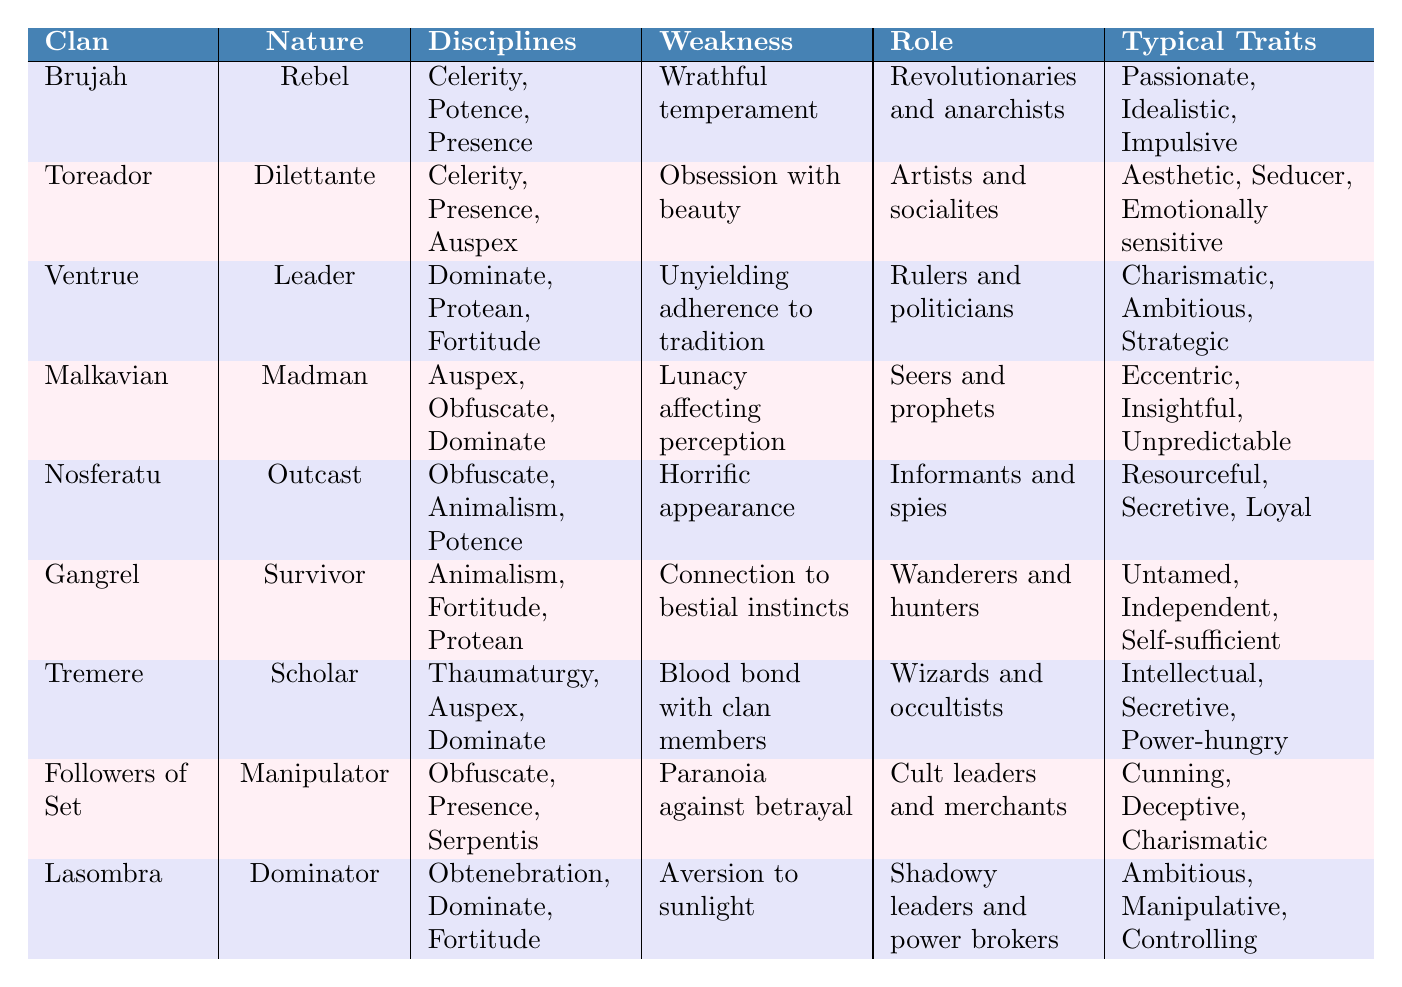What is the typical trait of the Ventrue clan? The table lists the typical traits of the Ventrue clan, which are Charismatic, Ambitious, and Strategic.
Answer: Charismatic, Ambitious, Strategic Which clan has the weakness of “Horrific appearance”? The table indicates that the Nosferatu clan has the weakness of “Horrific appearance.”
Answer: Nosferatu What are the disciplines practiced by the Toreador clan? According to the table, the Toreador clan practices Celerity, Presence, and Auspex.
Answer: Celerity, Presence, Auspex Is the Malkavian clan known for being leaders? The table specifies the Malkavian clan as having the nature of a "Madman," which does not align with being leaders.
Answer: No Which clan is described as "Wanderers and hunters"? The table clearly states that the Gangrel clan is described as "Wanderers and hunters."
Answer: Gangrel What is the nature of the Followers of Set? The table identifies the Followers of Set as having the nature of a "Manipulator."
Answer: Manipulator Which clans share the discipline of Auspex? The table indicates that the clans Toreador, Malkavian, and Tremere all practice Auspex, making a total of three clans.
Answer: 3 clans: Toreador, Malkavian, Tremere What is the role of the Lasombra clan? According to the table, the Lasombra clan is identified as "Shadowy leaders and power brokers."
Answer: Shadowy leaders and power brokers Which clan has "Connection to bestial instincts" as its weakness? The table lists that the Gangrel clan has "Connection to bestial instincts" as its weakness.
Answer: Gangrel If you add the number of typical traits of Brujah and Toreador together, how many traits do you have? The Brujah clan has 3 typical traits, and the Toreador clan also has 3 typical traits. Adding them gives a total of 6 typical traits.
Answer: 6 Which discipline is unique to the Tremere clan? The table lists Thaumaturgy as a discipline unique to the Tremere clan, as it is not shared with any other clan.
Answer: Thaumaturgy What is the weakness of the Ventrue clan? The weakness of the Ventrue clan, according to the table, is "Unyielding adherence to tradition."
Answer: Unyielding adherence to tradition How many clans are considered "Survivors"? Only one clan, Gangrel, is described with the nature of a "Survivor," as indicated by the table.
Answer: 1 clan: Gangrel What type of traits does the Malkavian clan exhibit? The Malkavian clan exhibits Eccentric, Insightful, and Unpredictable traits, as stated in the table.
Answer: Eccentric, Insightful, Unpredictable Which clan's role is described as "Informants and spies"? The Nosferatu clan is described in the table as fulfilling the role of "Informants and spies."
Answer: Nosferatu What is the nature of the Brujah clan? The nature of the Brujah clan, according to the table, is described as "Rebel."
Answer: Rebel 